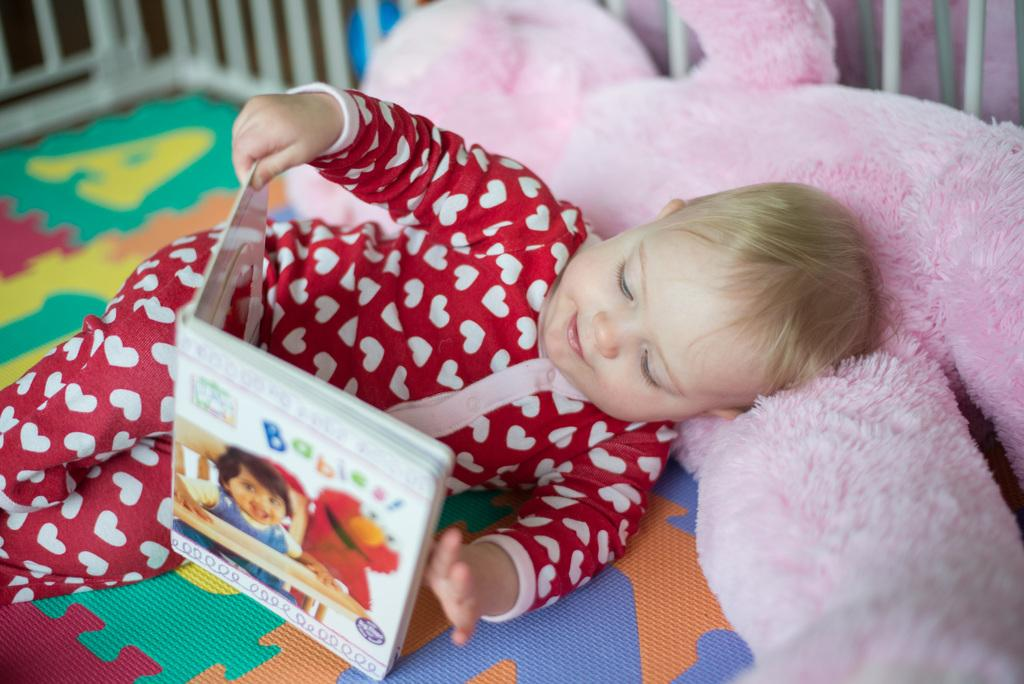What is the position of the kid in the image? The kid is lying in the image. What is the kid holding in the image? The kid is holding a book. What can be seen in the background of the image? There is a teddy bear in the background of the image. What type of architectural feature is visible in the image? There are grilles visible in the image. What is located at the bottom of the image? There is a bed at the bottom of the image. What type of work is the crook doing in the image? There is no crook present in the image, so it is not possible to answer that question. 